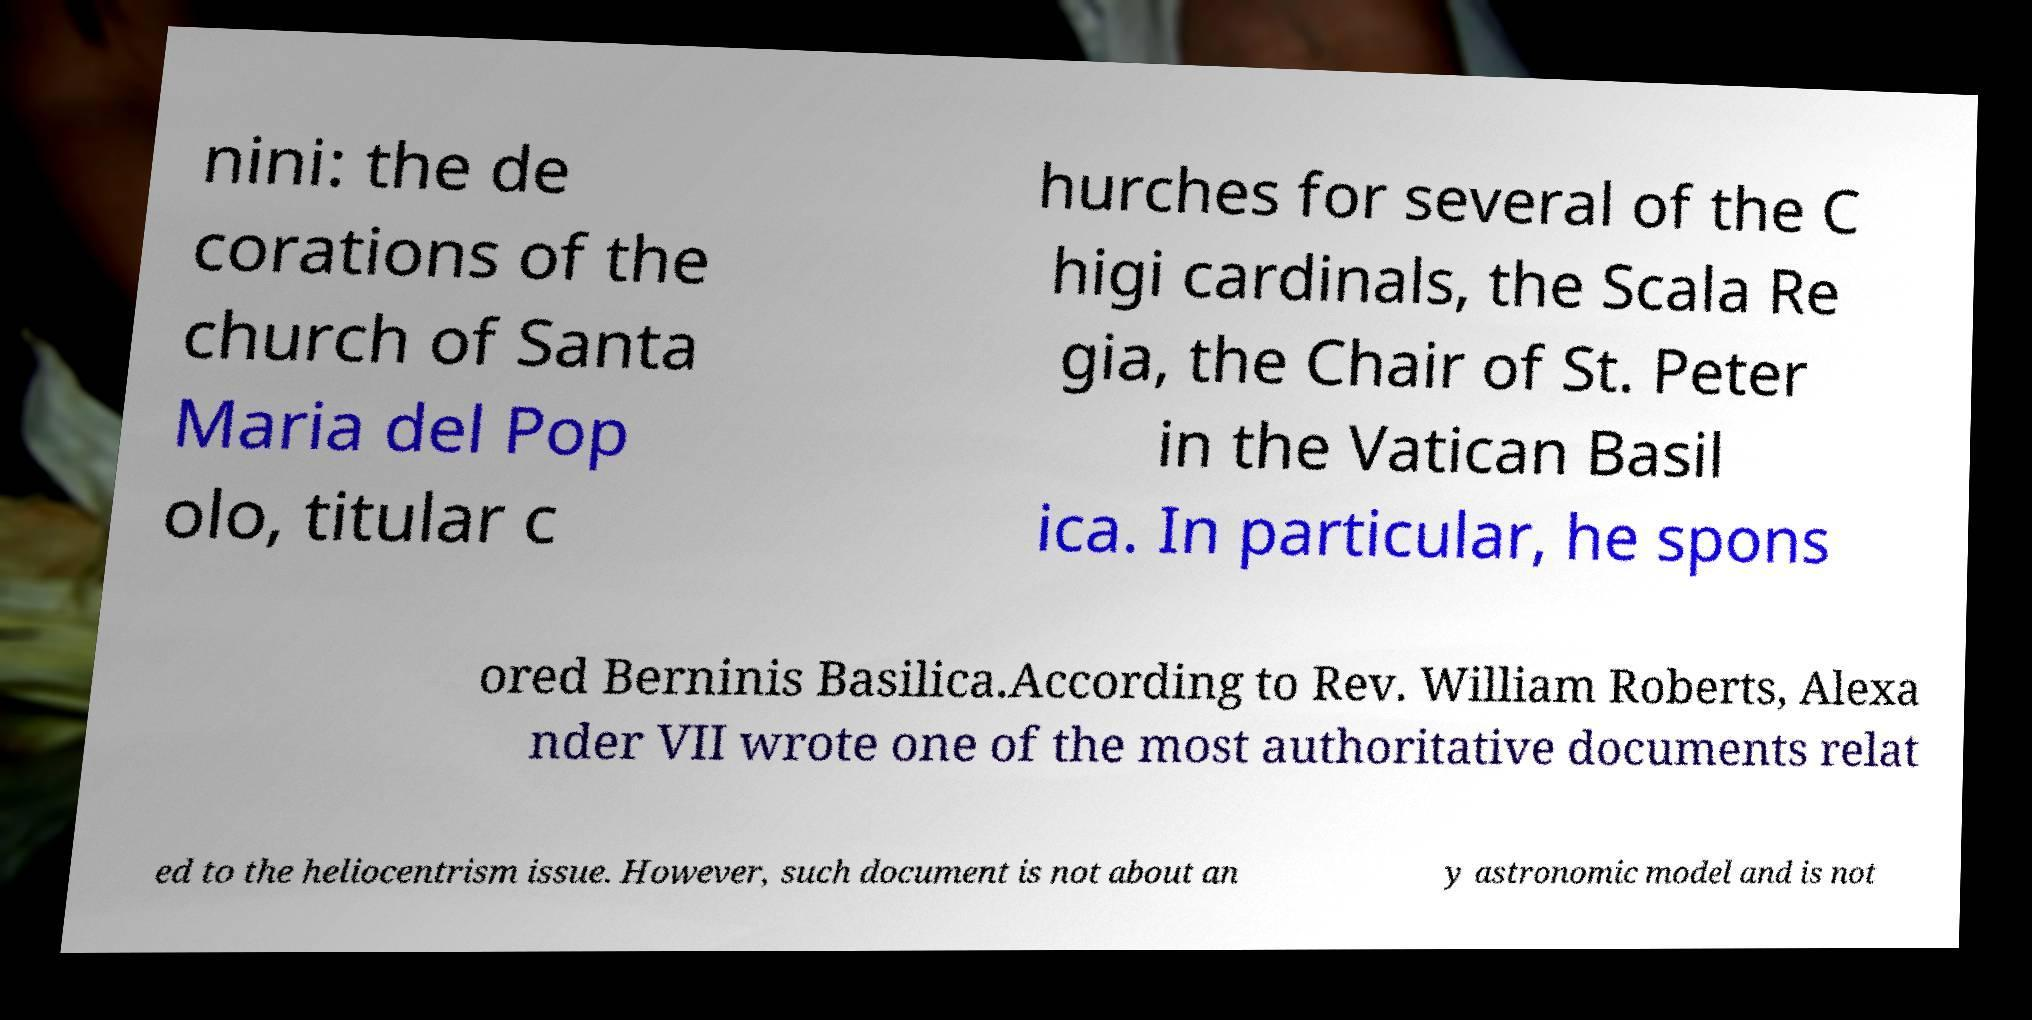Can you accurately transcribe the text from the provided image for me? nini: the de corations of the church of Santa Maria del Pop olo, titular c hurches for several of the C higi cardinals, the Scala Re gia, the Chair of St. Peter in the Vatican Basil ica. In particular, he spons ored Berninis Basilica.According to Rev. William Roberts, Alexa nder VII wrote one of the most authoritative documents relat ed to the heliocentrism issue. However, such document is not about an y astronomic model and is not 